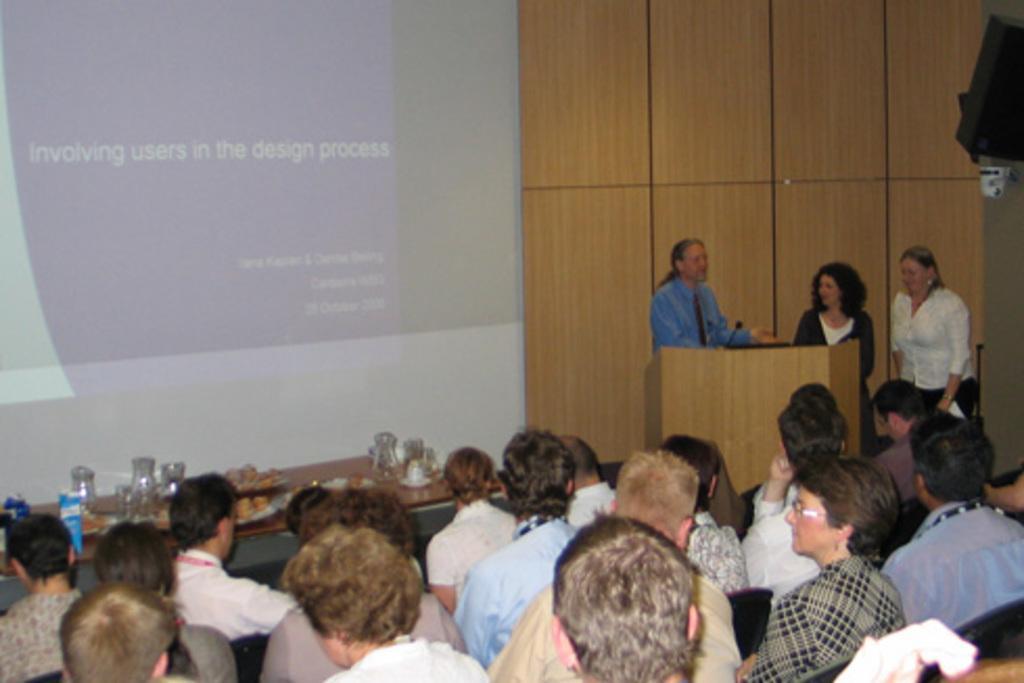Could you give a brief overview of what you see in this image? In this image at the bottom there are a group of people sitting on chairs, in the center there is one table. On the table there are some glasses and some other objects, on the right side there is one podium and mike and three persons are sitting and in the background there is a wooden board and screen and some object. 